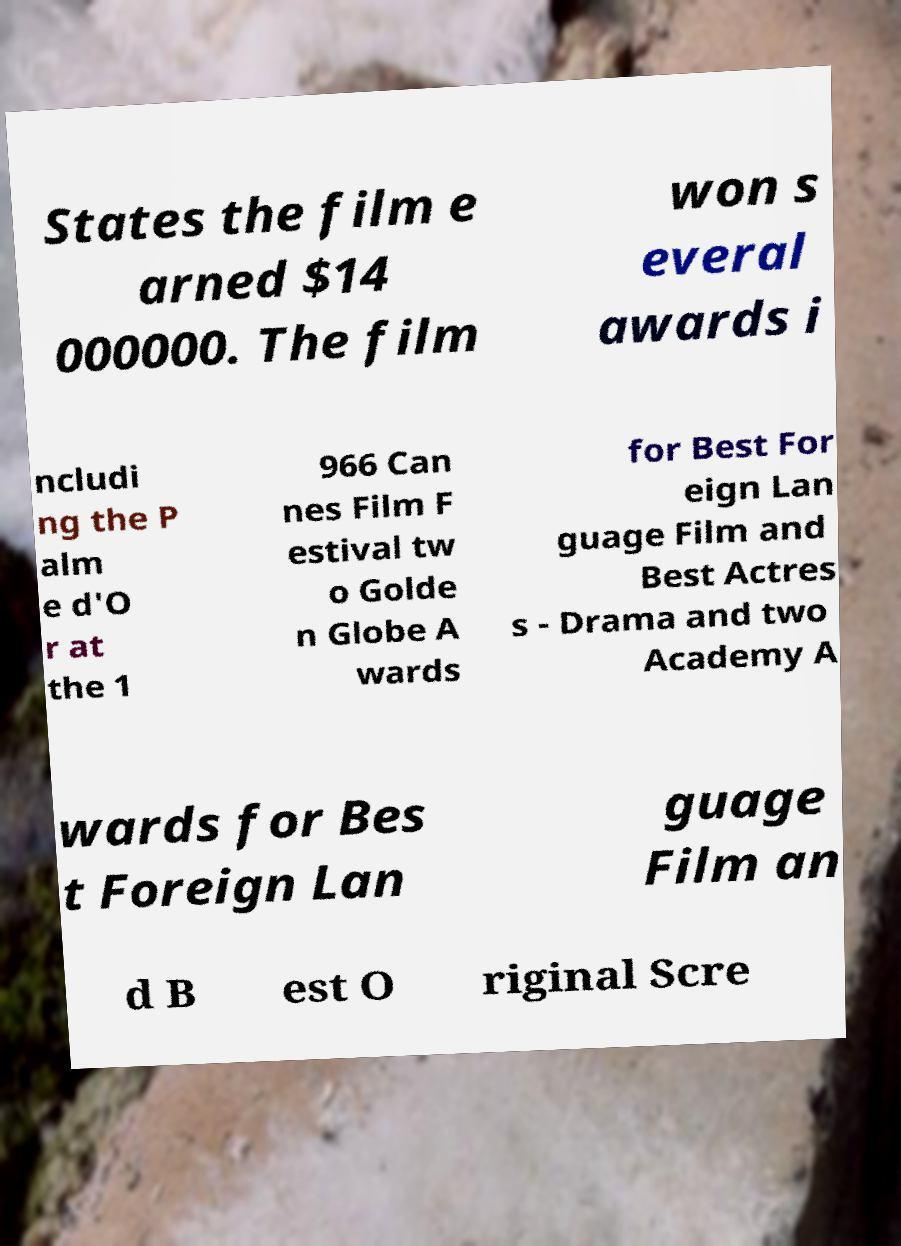Can you accurately transcribe the text from the provided image for me? States the film e arned $14 000000. The film won s everal awards i ncludi ng the P alm e d'O r at the 1 966 Can nes Film F estival tw o Golde n Globe A wards for Best For eign Lan guage Film and Best Actres s - Drama and two Academy A wards for Bes t Foreign Lan guage Film an d B est O riginal Scre 